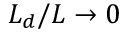Convert formula to latex. <formula><loc_0><loc_0><loc_500><loc_500>L _ { d } / L \to 0</formula> 